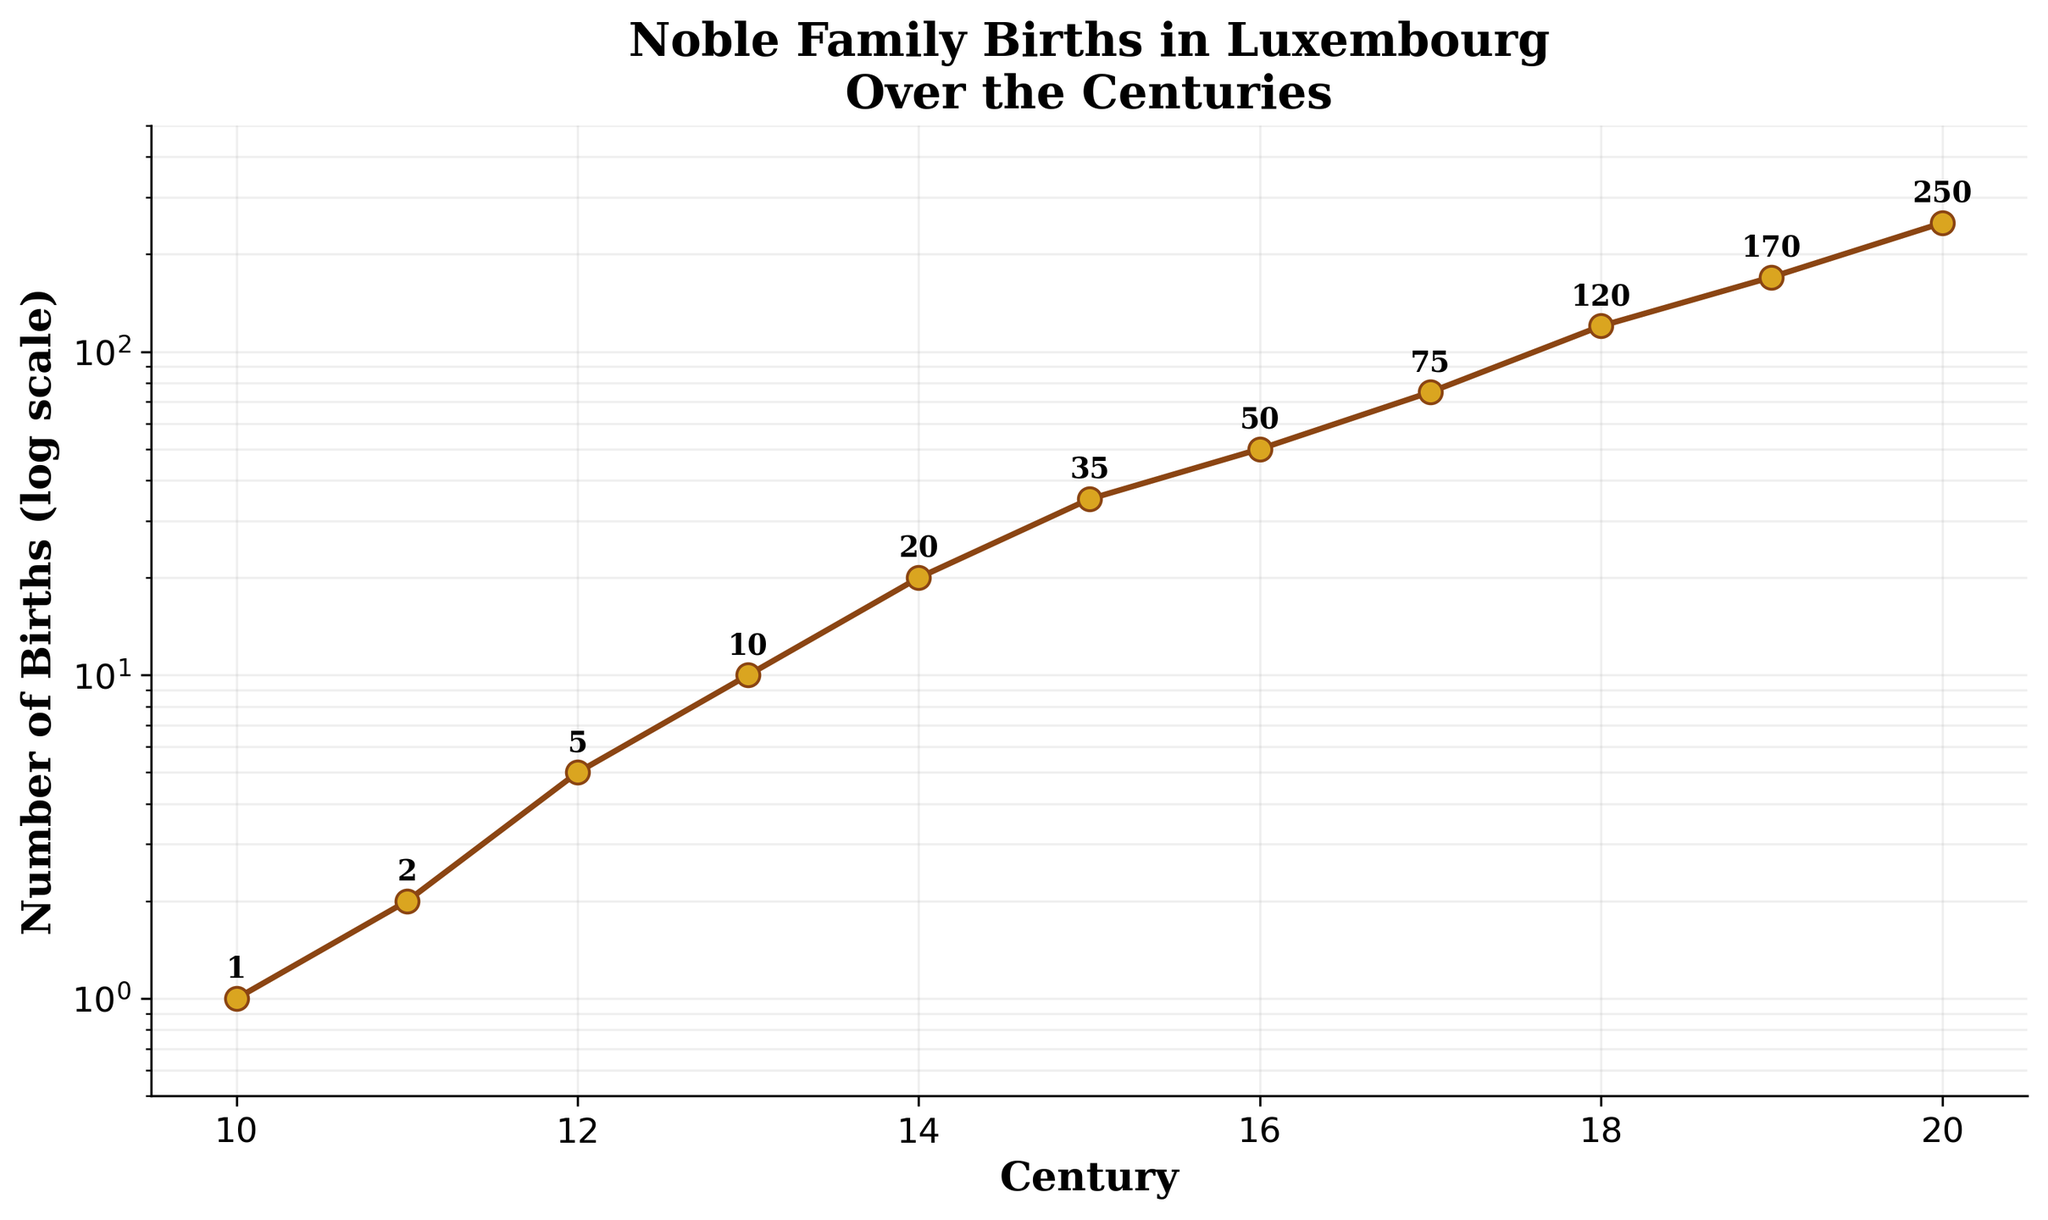What is the title of the plot? The title of the plot is prominently displayed at the top. It summarizes the focus of the graph, which is about births in noble families over time.
Answer: Noble Family Births in Luxembourg Over the Centuries How many centuries are covered in the plot? The x-axis marks the centuries from the 10th to the 20th. By counting these, the total number of centuries covered is calculated.
Answer: 11 How is the y-axis scaled, and what is its range? The y-axis is labeled as a log scale, which is used to better represent data with large ranges in values. The range is given from 0.5 to 500.
Answer: Logarithmic; 0.5 to 500 In which century did the number of births first exceed 100? By following the y-axis and identifying where the curve crosses the 100 mark, it is evident that this occurs in the 18th century.
Answer: 18th century What was the number of births in the 14th century? The number is marked near the corresponding data point for the 14th century, showing the value directly.
Answer: 20 By how much did the number of births increase from the 15th to the 16th century? The values for the 15th and 16th centuries are 35 and 50, respectively. Subtracting 35 from 50 gives the increase.
Answer: 15 Which century experienced the highest number of births, and what is the value? By locating the highest data point on the plot, the 20th century stands out, showing the highest number of births at 250.
Answer: 20th century, 250 How many times greater were the births in the 20th century compared to the 10th century? Dividing the 20th-century births (250) by the 10th-century births (1) gives the multiplication factor.
Answer: 250 times What is the trend in the number of births from the 10th to the 20th century? The line plot continuously trends upwards, indicating a consistent increase in the number of births over time.
Answer: Increasing By what factor did the number of births increase from the 17th to the 18th century? The 17th and 18th centuries have 75 and 120 births, respectively. Dividing 120 by 75 gives the factor of increase.
Answer: 1.6 times 